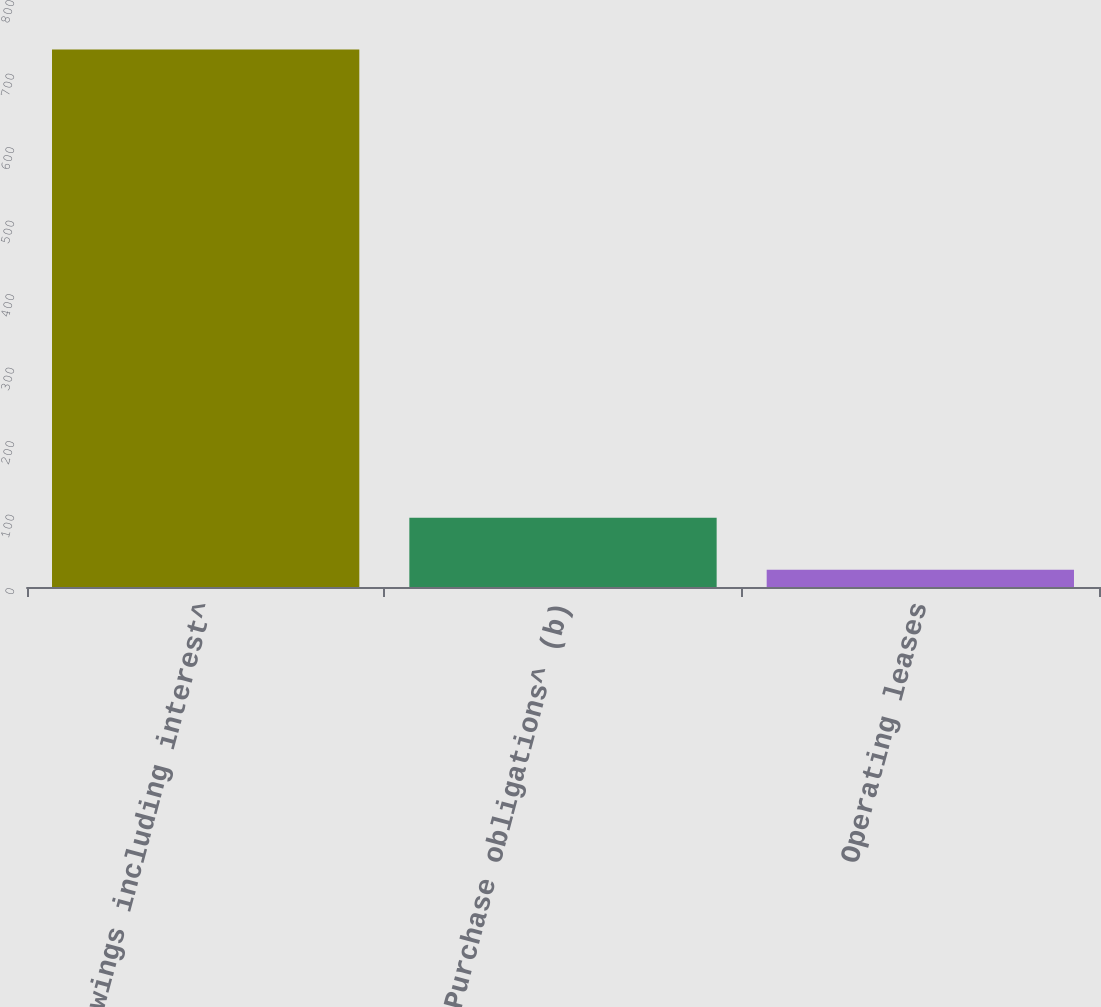Convert chart. <chart><loc_0><loc_0><loc_500><loc_500><bar_chart><fcel>Borrowings including interest^<fcel>Purchase obligations^ (b)<fcel>Operating leases<nl><fcel>731.3<fcel>94.28<fcel>23.5<nl></chart> 